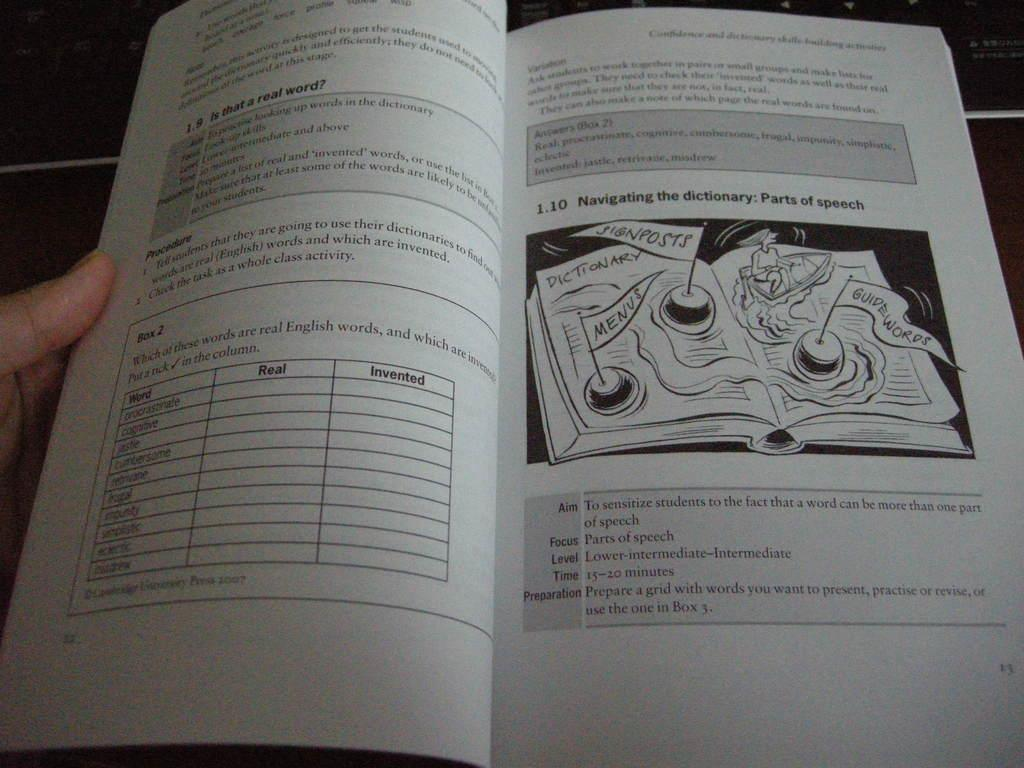<image>
Present a compact description of the photo's key features. A person has a textbook open to a page about Parts of speech. 